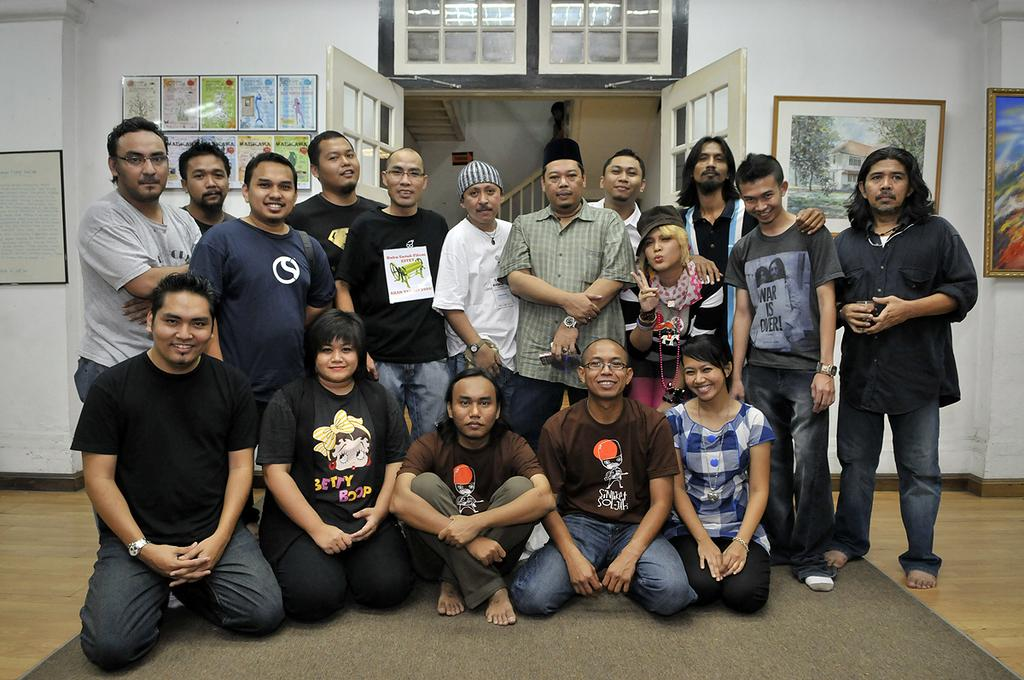How many persons are in the image? There is a group of persons in the image. What are the persons in the image doing? Some of the persons are sitting on the floor, while others are standing on the floor. What can be seen in the background of the image? There is a background in the image, which includes photo frames, a door, stairs, and a wall. What type of humor can be seen in the expressions of the persons in the image? There is no indication of humor or expressions in the image, as it only shows a group of persons sitting and standing. How many eggs are visible in the image? There are no eggs present in the image. 